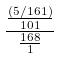Convert formula to latex. <formula><loc_0><loc_0><loc_500><loc_500>\frac { \frac { ( 5 / 1 6 1 ) } { 1 0 1 } } { \frac { 1 6 8 } { 1 } }</formula> 